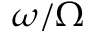<formula> <loc_0><loc_0><loc_500><loc_500>\omega / \Omega</formula> 